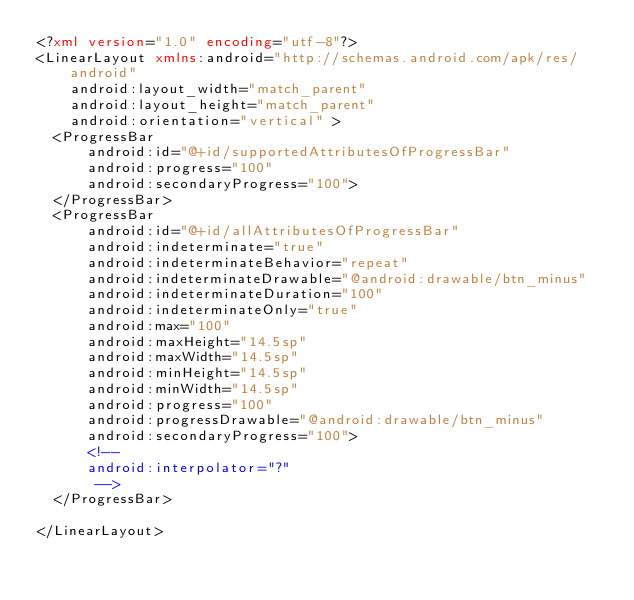<code> <loc_0><loc_0><loc_500><loc_500><_XML_><?xml version="1.0" encoding="utf-8"?>
<LinearLayout xmlns:android="http://schemas.android.com/apk/res/android"
    android:layout_width="match_parent"
    android:layout_height="match_parent"
    android:orientation="vertical" >
	<ProgressBar 
	    android:id="@+id/supportedAttributesOfProgressBar"
	    android:progress="100"
	    android:secondaryProgress="100">
	</ProgressBar>
	<ProgressBar 
	    android:id="@+id/allAttributesOfProgressBar"
	    android:indeterminate="true"
	    android:indeterminateBehavior="repeat"
	    android:indeterminateDrawable="@android:drawable/btn_minus"
	    android:indeterminateDuration="100"
	    android:indeterminateOnly="true"
	    android:max="100"
	    android:maxHeight="14.5sp"
	    android:maxWidth="14.5sp"
	    android:minHeight="14.5sp"
	    android:minWidth="14.5sp"
	    android:progress="100"
	    android:progressDrawable="@android:drawable/btn_minus"
	    android:secondaryProgress="100">
	    <!-- 
	    android:interpolator="?"
	     -->
	</ProgressBar>

</LinearLayout></code> 